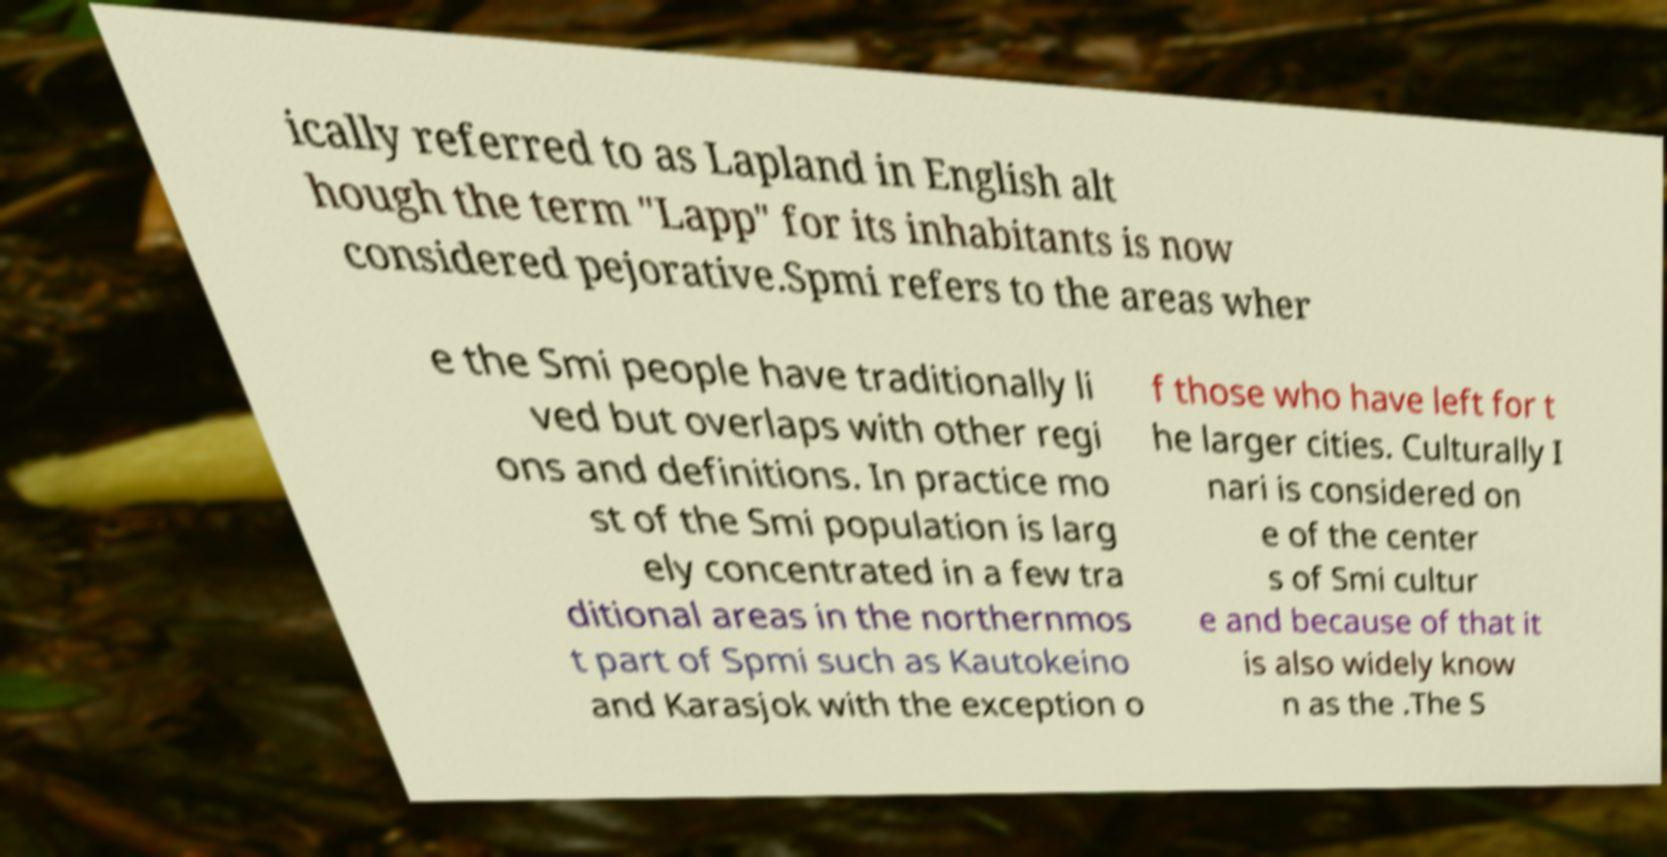There's text embedded in this image that I need extracted. Can you transcribe it verbatim? ically referred to as Lapland in English alt hough the term "Lapp" for its inhabitants is now considered pejorative.Spmi refers to the areas wher e the Smi people have traditionally li ved but overlaps with other regi ons and definitions. In practice mo st of the Smi population is larg ely concentrated in a few tra ditional areas in the northernmos t part of Spmi such as Kautokeino and Karasjok with the exception o f those who have left for t he larger cities. Culturally I nari is considered on e of the center s of Smi cultur e and because of that it is also widely know n as the .The S 